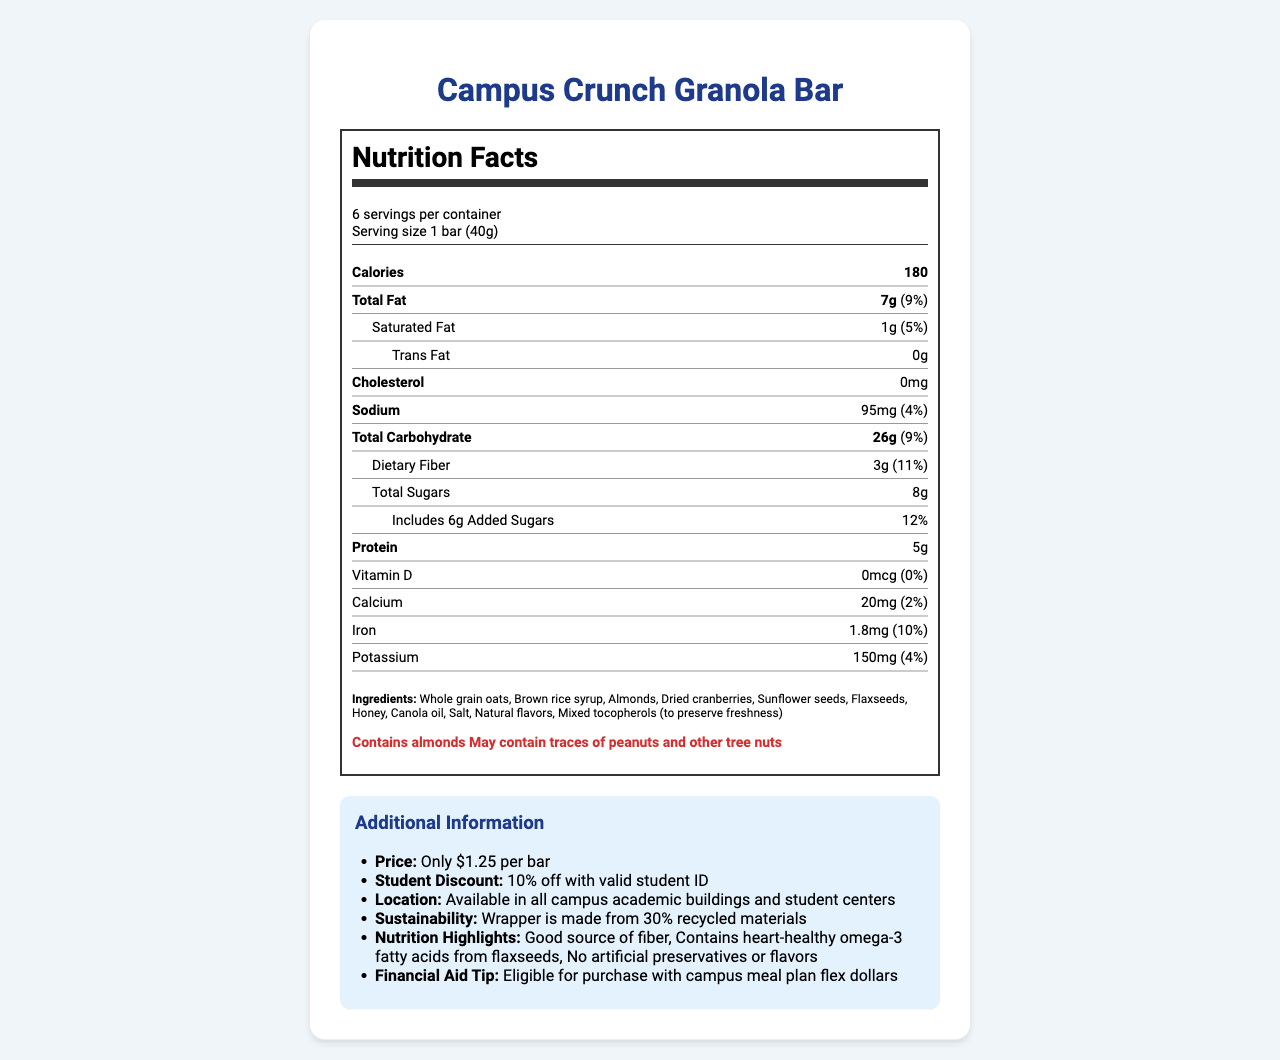what is the serving size of the Campus Crunch Granola Bar? The serving size is explicitly stated as "1 bar (40g)" in the nutrition facts section.
Answer: 1 bar (40g) how many calories are in one serving of the granola bar? The number of calories per serving is listed as 180 under the "Calories" section.
Answer: 180 how much protein is in one bar? The protein content per serving is labeled as 5g in the nutrition facts.
Answer: 5g what allergens does the granola bar contain? The allergen information is provided at the end of the nutrition label, noting "Contains almonds" and "May contain traces of peanuts and other tree nuts."
Answer: Contains almonds, May contain traces of peanuts and other tree nuts how many grams of dietary fiber are in one serving? The dietary fiber content is listed as 3g under the "Total Carbohydrate" section in the nutrition facts.
Answer: 3g Which of the following ingredients is NOT in the granola bar? A. Brown rice syrup B. Whole grain oats C. Peanuts D. Flaxseeds Peanuts are not listed in the ingredients, while the other options are.
Answer: C What is the daily value percentage for saturated fat? A. 3% B. 5% C. 7% The daily value percentage for saturated fat is noted as 5% in the nutrition facts.
Answer: B Does the granola bar contain any cholesterol? The nutrition facts state "Cholesterol 0mg," which means there is no cholesterol in the granola bar.
Answer: No Summarize the main idea of the document The document presents comprehensive information on the granola bar's nutrition, ingredients, allergens, and extra details beneficial to students.
Answer: The document provides detailed nutritional information about the Campus Crunch Granola Bar, including serving size, calories, fat content, and other nutrients. It also lists ingredients, allergens, and additional information such as sustainability features, pricing, student discounts, and the option to purchase with meal plan flex dollars. Is the wrapper of the granola bar sustainable? The additional information section states that the wrapper is made from 30% recycled materials.
Answer: Yes What is the total amount of added sugars in one bar? The total added sugars are listed as 6g under the "Includes" subsection of the sugars category.
Answer: 6g How much does one bar cost without any discounts? The document states that the bar is priced at $1.25 each.
Answer: $1.25 What percentage of the daily value of iron does the granola bar provide? The percentage of the daily value for iron is mentioned as 10% in the nutrition facts.
Answer: 10% What are the three main points highlighted in the 'Nutrition Highlights'? The additional information section lists these three points as the "Nutrition Highlights."
Answer: Good source of fiber, Contains heart-healthy omega-3 fatty acids from flaxseeds, No artificial preservatives or flavors Can this granola bar be purchased using a campus meal plan? The additional information mentions that the granola bars are eligible for purchase with campus meal plan flex dollars.
Answer: Yes What is the ingredient used to preserve freshness? The ingredient list mentions "Mixed tocopherols (to preserve freshness)."
Answer: Mixed tocopherols Which vitamins or minerals are not provided by the granola bar? The nutrition facts state 0mcg and 0% Daily Value for Vitamin D.
Answer: Vitamin D Is the daily value percentage of sodium higher or lower than that for total carbohydrate? The daily value percentage for sodium is 4%, whereas for total carbohydrate, it is 9%.
Answer: Lower Where are the vending machines located that sell this granola bar? The additional information section specifies that the granola bar is available in vending machines in all campus academic buildings and student centers.
Answer: Available in all campus academic buildings and student centers What kind of oil is used in the granola bar? The ingredient list includes "Canola oil."
Answer: Canola oil I have a peanut allergy; is it safe for me to consume this granola bar? The allergens section states that the granola bar may contain traces of peanuts, which is not definitive for someone with a peanut allergy to determine safety.
Answer: Not enough information 